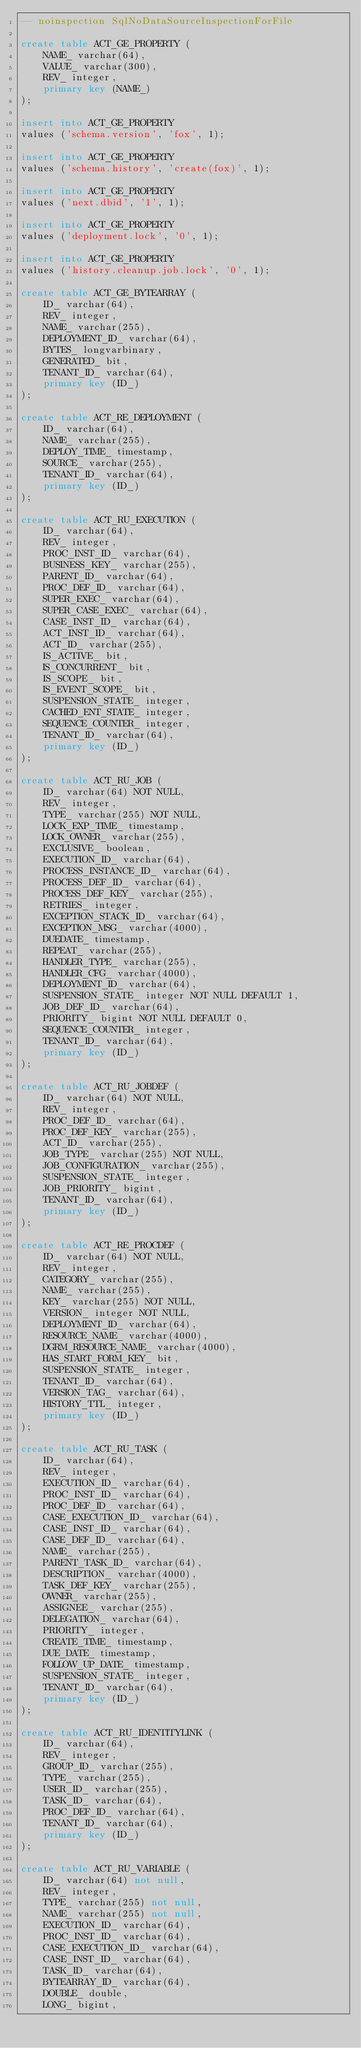Convert code to text. <code><loc_0><loc_0><loc_500><loc_500><_SQL_>-- noinspection SqlNoDataSourceInspectionForFile

create table ACT_GE_PROPERTY (
    NAME_ varchar(64),
    VALUE_ varchar(300),
    REV_ integer,
    primary key (NAME_)
);

insert into ACT_GE_PROPERTY
values ('schema.version', 'fox', 1);

insert into ACT_GE_PROPERTY
values ('schema.history', 'create(fox)', 1);

insert into ACT_GE_PROPERTY
values ('next.dbid', '1', 1);

insert into ACT_GE_PROPERTY
values ('deployment.lock', '0', 1);

insert into ACT_GE_PROPERTY
values ('history.cleanup.job.lock', '0', 1);

create table ACT_GE_BYTEARRAY (
    ID_ varchar(64),
    REV_ integer,
    NAME_ varchar(255),
    DEPLOYMENT_ID_ varchar(64),
    BYTES_ longvarbinary,
    GENERATED_ bit,
    TENANT_ID_ varchar(64),
    primary key (ID_)
);

create table ACT_RE_DEPLOYMENT (
    ID_ varchar(64),
    NAME_ varchar(255),
    DEPLOY_TIME_ timestamp,
    SOURCE_ varchar(255),
    TENANT_ID_ varchar(64),
    primary key (ID_)
);

create table ACT_RU_EXECUTION (
    ID_ varchar(64),
    REV_ integer,
    PROC_INST_ID_ varchar(64),
    BUSINESS_KEY_ varchar(255),
    PARENT_ID_ varchar(64),
    PROC_DEF_ID_ varchar(64),
    SUPER_EXEC_ varchar(64),
    SUPER_CASE_EXEC_ varchar(64),
    CASE_INST_ID_ varchar(64),
    ACT_INST_ID_ varchar(64),
    ACT_ID_ varchar(255),
    IS_ACTIVE_ bit,
    IS_CONCURRENT_ bit,
    IS_SCOPE_ bit,
    IS_EVENT_SCOPE_ bit,
    SUSPENSION_STATE_ integer,
    CACHED_ENT_STATE_ integer,
    SEQUENCE_COUNTER_ integer,
    TENANT_ID_ varchar(64),
    primary key (ID_)
);

create table ACT_RU_JOB (
    ID_ varchar(64) NOT NULL,
    REV_ integer,
    TYPE_ varchar(255) NOT NULL,
    LOCK_EXP_TIME_ timestamp,
    LOCK_OWNER_ varchar(255),
    EXCLUSIVE_ boolean,
    EXECUTION_ID_ varchar(64),
    PROCESS_INSTANCE_ID_ varchar(64),
    PROCESS_DEF_ID_ varchar(64),
    PROCESS_DEF_KEY_ varchar(255),
    RETRIES_ integer,
    EXCEPTION_STACK_ID_ varchar(64),
    EXCEPTION_MSG_ varchar(4000),
    DUEDATE_ timestamp,
    REPEAT_ varchar(255),
    HANDLER_TYPE_ varchar(255),
    HANDLER_CFG_ varchar(4000),
    DEPLOYMENT_ID_ varchar(64),
    SUSPENSION_STATE_ integer NOT NULL DEFAULT 1,
    JOB_DEF_ID_ varchar(64),
    PRIORITY_ bigint NOT NULL DEFAULT 0,
    SEQUENCE_COUNTER_ integer,
    TENANT_ID_ varchar(64),
    primary key (ID_)
);

create table ACT_RU_JOBDEF (
    ID_ varchar(64) NOT NULL,
    REV_ integer,
    PROC_DEF_ID_ varchar(64),
    PROC_DEF_KEY_ varchar(255),
    ACT_ID_ varchar(255),
    JOB_TYPE_ varchar(255) NOT NULL,
    JOB_CONFIGURATION_ varchar(255),
    SUSPENSION_STATE_ integer,
    JOB_PRIORITY_ bigint,
    TENANT_ID_ varchar(64),
    primary key (ID_)
);

create table ACT_RE_PROCDEF (
    ID_ varchar(64) NOT NULL,
    REV_ integer,
    CATEGORY_ varchar(255),
    NAME_ varchar(255),
    KEY_ varchar(255) NOT NULL,
    VERSION_ integer NOT NULL,
    DEPLOYMENT_ID_ varchar(64),
    RESOURCE_NAME_ varchar(4000),
    DGRM_RESOURCE_NAME_ varchar(4000),
    HAS_START_FORM_KEY_ bit,
    SUSPENSION_STATE_ integer,
    TENANT_ID_ varchar(64),
    VERSION_TAG_ varchar(64),
    HISTORY_TTL_ integer,
    primary key (ID_)
);

create table ACT_RU_TASK (
    ID_ varchar(64),
    REV_ integer,
    EXECUTION_ID_ varchar(64),
    PROC_INST_ID_ varchar(64),
    PROC_DEF_ID_ varchar(64),
    CASE_EXECUTION_ID_ varchar(64),
    CASE_INST_ID_ varchar(64),
    CASE_DEF_ID_ varchar(64),
    NAME_ varchar(255),
    PARENT_TASK_ID_ varchar(64),
    DESCRIPTION_ varchar(4000),
    TASK_DEF_KEY_ varchar(255),
    OWNER_ varchar(255),
    ASSIGNEE_ varchar(255),
    DELEGATION_ varchar(64),
    PRIORITY_ integer,
    CREATE_TIME_ timestamp,
    DUE_DATE_ timestamp,
    FOLLOW_UP_DATE_ timestamp,
    SUSPENSION_STATE_ integer,
    TENANT_ID_ varchar(64),
    primary key (ID_)
);

create table ACT_RU_IDENTITYLINK (
    ID_ varchar(64),
    REV_ integer,
    GROUP_ID_ varchar(255),
    TYPE_ varchar(255),
    USER_ID_ varchar(255),
    TASK_ID_ varchar(64),
    PROC_DEF_ID_ varchar(64),
    TENANT_ID_ varchar(64),
    primary key (ID_)
);

create table ACT_RU_VARIABLE (
    ID_ varchar(64) not null,
    REV_ integer,
    TYPE_ varchar(255) not null,
    NAME_ varchar(255) not null,
    EXECUTION_ID_ varchar(64),
    PROC_INST_ID_ varchar(64),
    CASE_EXECUTION_ID_ varchar(64),
    CASE_INST_ID_ varchar(64),
    TASK_ID_ varchar(64),
    BYTEARRAY_ID_ varchar(64),
    DOUBLE_ double,
    LONG_ bigint,</code> 